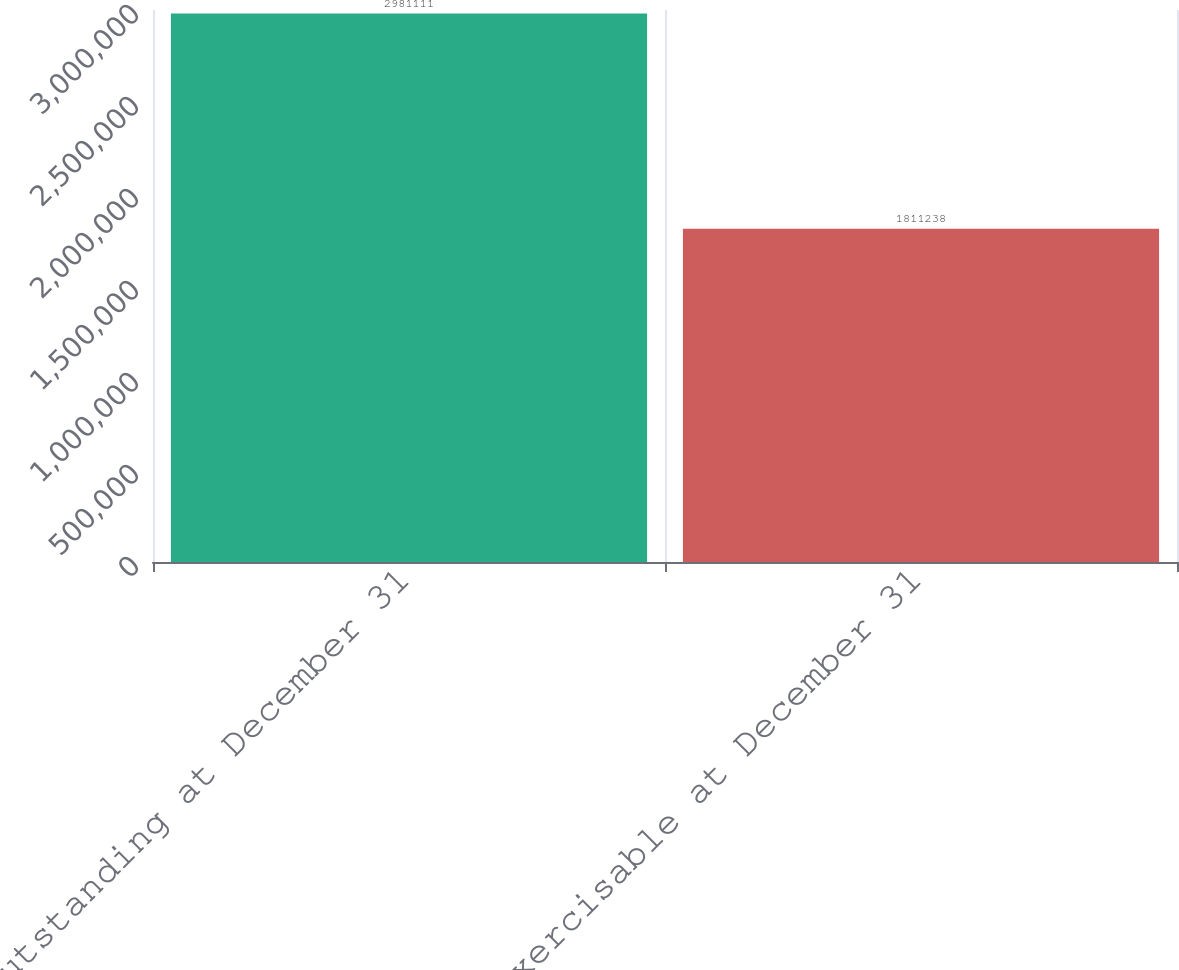Convert chart. <chart><loc_0><loc_0><loc_500><loc_500><bar_chart><fcel>Outstanding at December 31<fcel>Exercisable at December 31<nl><fcel>2.98111e+06<fcel>1.81124e+06<nl></chart> 